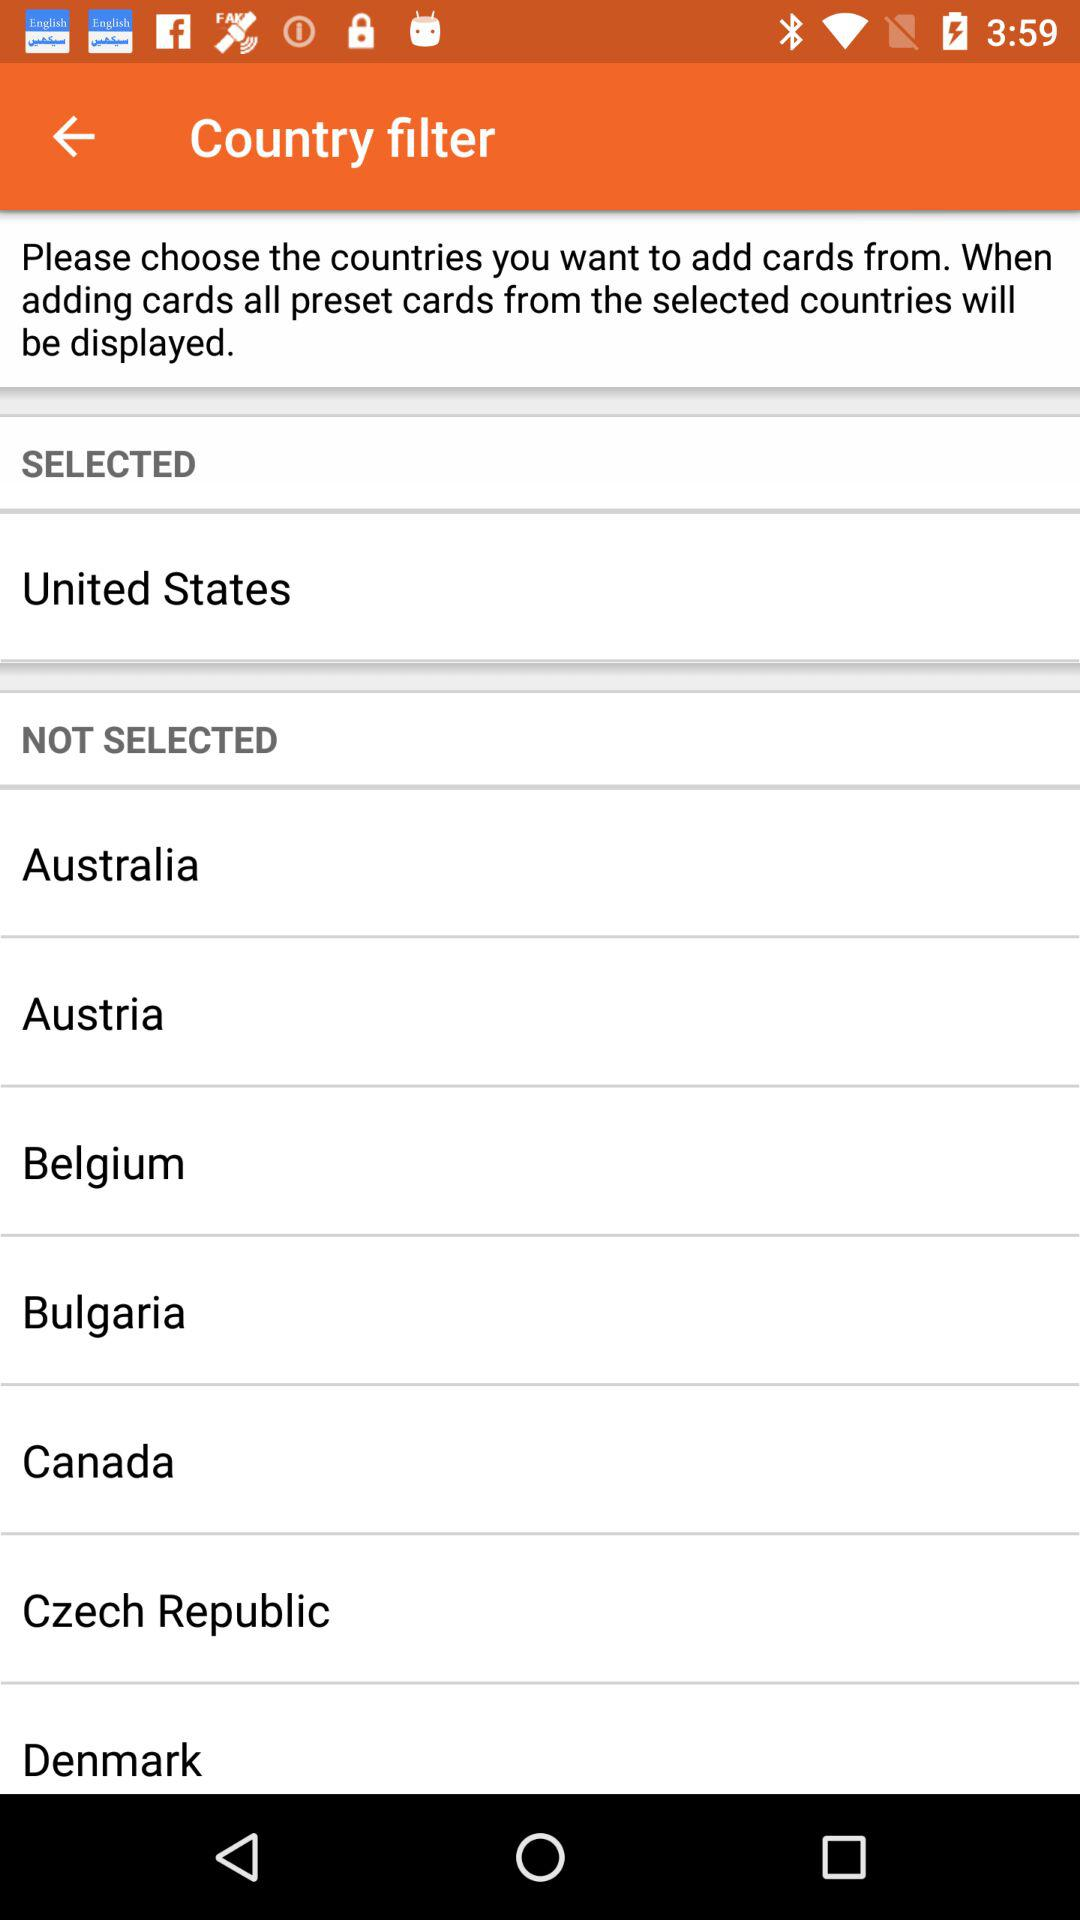How many countries are selected?
Answer the question using a single word or phrase. 1 